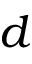<formula> <loc_0><loc_0><loc_500><loc_500>d</formula> 